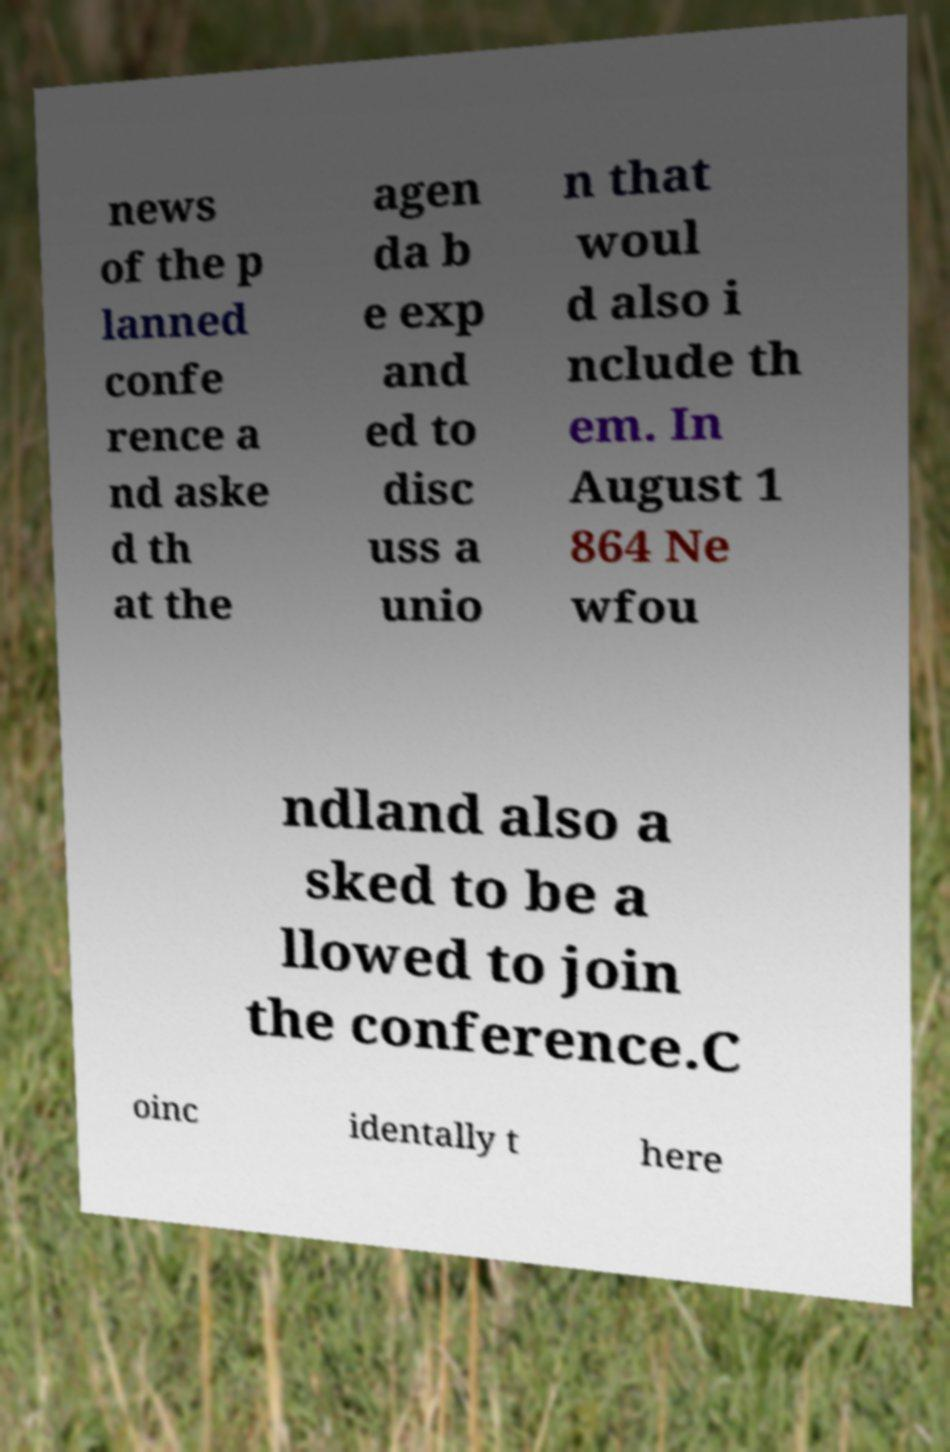There's text embedded in this image that I need extracted. Can you transcribe it verbatim? news of the p lanned confe rence a nd aske d th at the agen da b e exp and ed to disc uss a unio n that woul d also i nclude th em. In August 1 864 Ne wfou ndland also a sked to be a llowed to join the conference.C oinc identally t here 